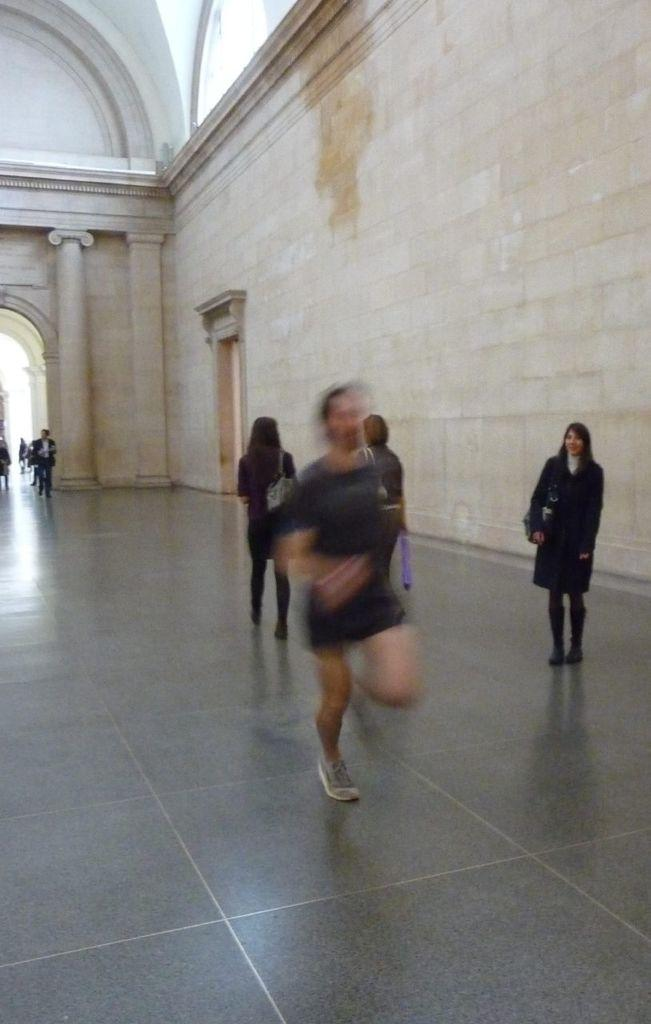How many people are in the image? There is a group of people in the image. What are some of the people in the image doing? Some people are walking, and there is a person running. Can you describe the running person's position in the image? The running person is on the floor and wall. What can be seen in the background of the image? There is an arch in the background of the image. What type of neck accessory is the running person wearing in the image? There is no mention of a neck accessory in the image, as the focus is on the people's actions and positions. 